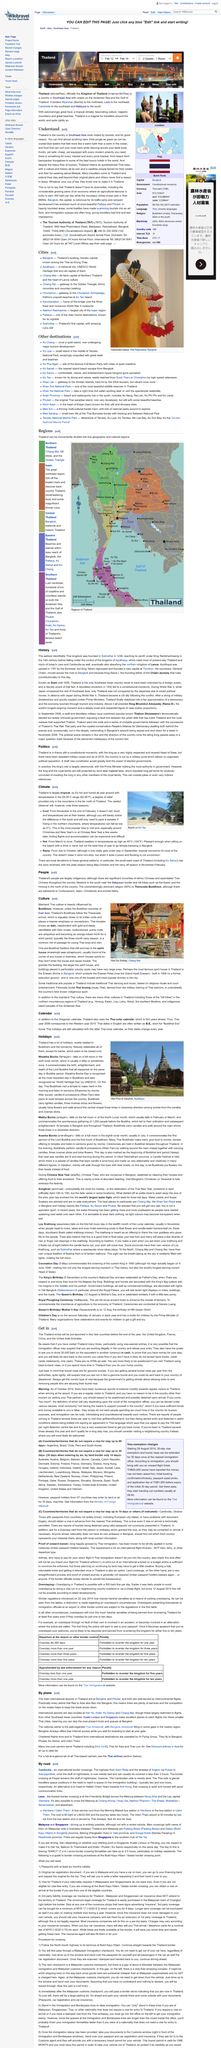Give some essential details in this illustration. Thailand is located in Southeast Asia. From February 12 to February 14, I will be checking in and out. The Kingdom of Thailand is officially known as Thailand. What place is largely tropical? Thailand is largely tropical. Yes, it is cool one of the seasons in Thailand. 